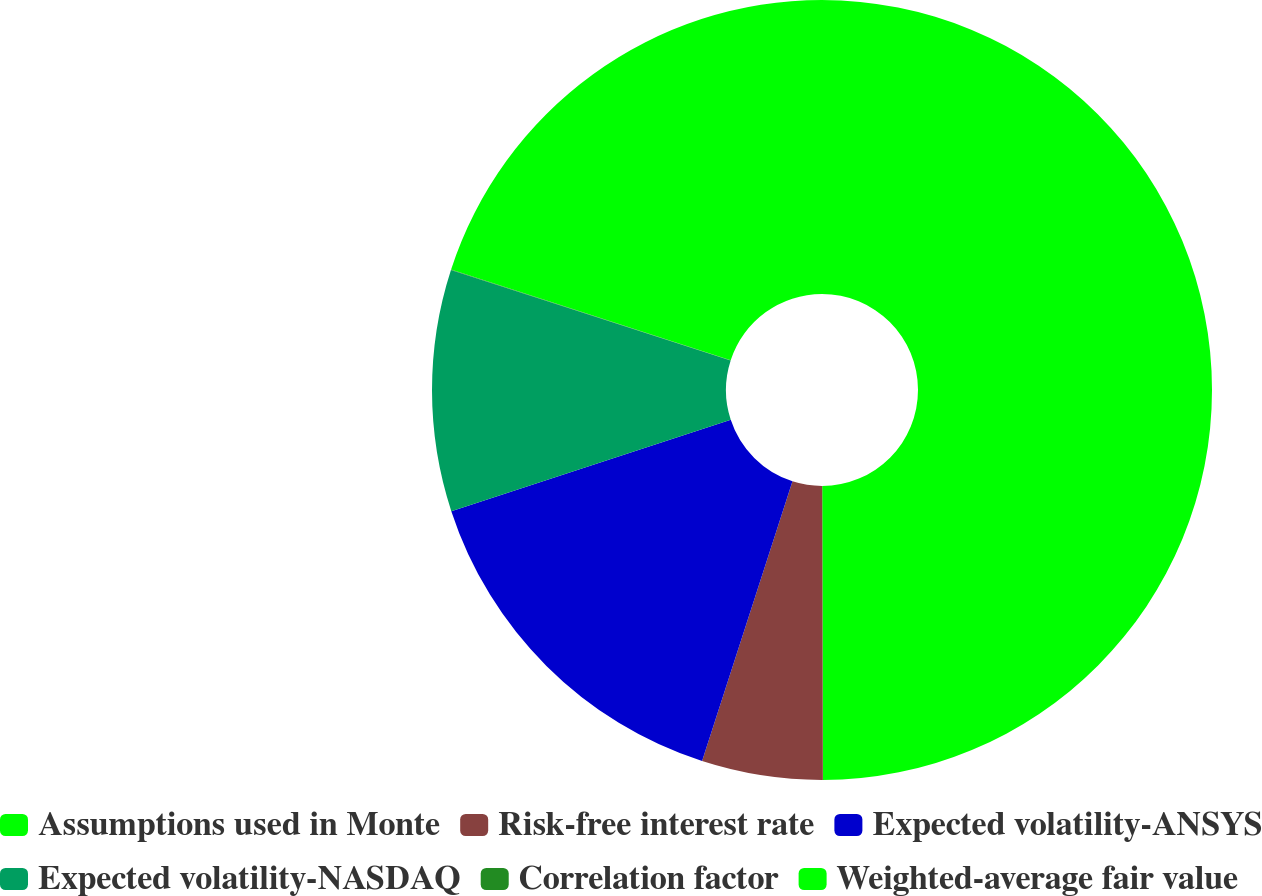<chart> <loc_0><loc_0><loc_500><loc_500><pie_chart><fcel>Assumptions used in Monte<fcel>Risk-free interest rate<fcel>Expected volatility-ANSYS<fcel>Expected volatility-NASDAQ<fcel>Correlation factor<fcel>Weighted-average fair value<nl><fcel>49.97%<fcel>5.01%<fcel>15.0%<fcel>10.01%<fcel>0.02%<fcel>20.0%<nl></chart> 